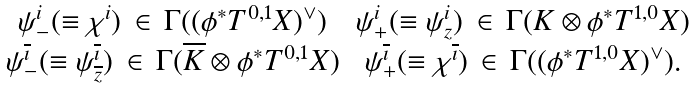Convert formula to latex. <formula><loc_0><loc_0><loc_500><loc_500>\begin{array} { c c } \psi _ { - } ^ { i } ( \equiv \chi ^ { i } ) \, \in \, \Gamma ( ( \phi ^ { * } T ^ { 0 , 1 } X ) ^ { \vee } ) & \psi _ { + } ^ { i } ( \equiv \psi _ { z } ^ { i } ) \, \in \, \Gamma ( K \otimes \phi ^ { * } T ^ { 1 , 0 } X ) \\ \psi _ { - } ^ { \overline { \imath } } ( \equiv \psi _ { \overline { z } } ^ { \overline { \imath } } ) \, \in \, \Gamma ( \overline { K } \otimes \phi ^ { * } T ^ { 0 , 1 } X ) & \psi _ { + } ^ { \overline { \imath } } ( \equiv \chi ^ { \overline { \imath } } ) \, \in \, \Gamma ( ( \phi ^ { * } T ^ { 1 , 0 } X ) ^ { \vee } ) . \end{array}</formula> 